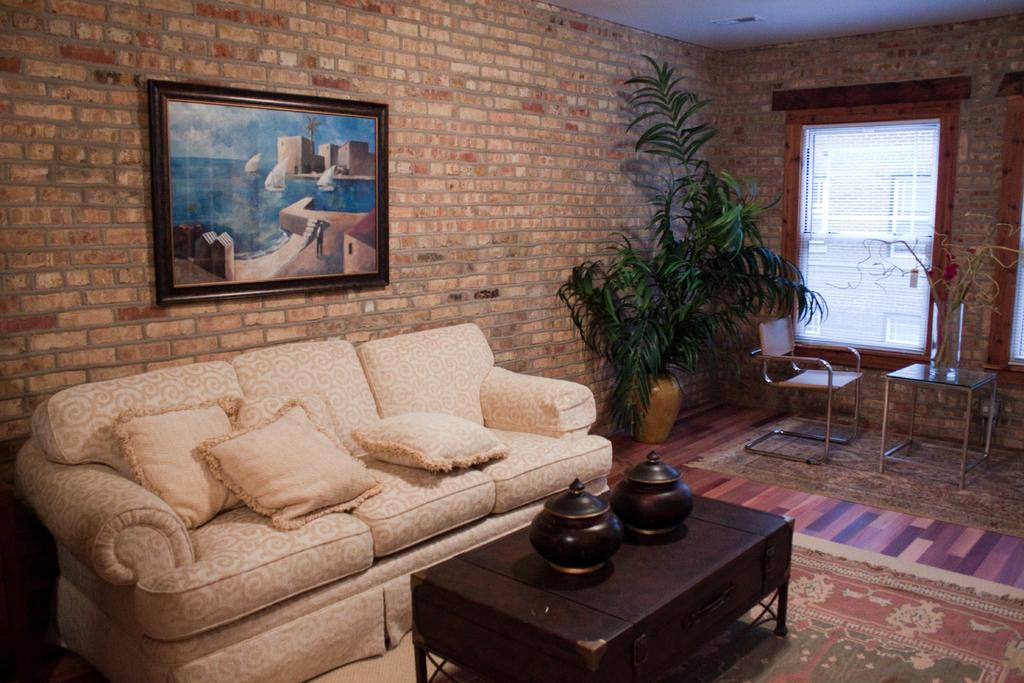What type of furniture is present in the image? There is a sofa in the image. What can be seen on the wall in the image? There is a photo frame on the wall in the image. What objects are on the table in the image? There are two pots on the table in the image. Is there any blood visible on the sofa in the image? No, there is no blood visible on the sofa in the image. Can you tell me where the decision was made in the image? There is no mention of a decision being made in the image, so it cannot be determined from the provided facts. 